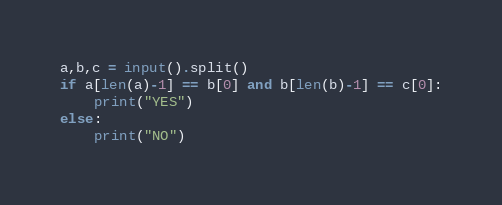Convert code to text. <code><loc_0><loc_0><loc_500><loc_500><_Python_>a,b,c = input().split()
if a[len(a)-1] == b[0] and b[len(b)-1] == c[0]:
    print("YES")
else:
    print("NO")</code> 